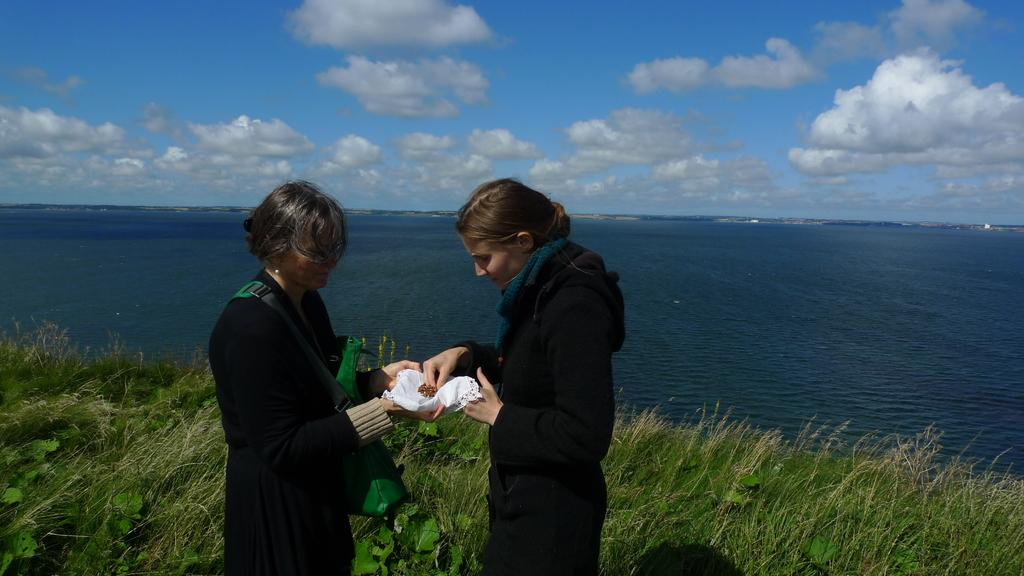How many people are in the image? There are two persons standing in the image. What are the persons holding in the image? The persons are holding an object. What type of natural environment is visible in the image? There is grass, plants, and water visible in the image. What can be seen in the background of the image? The sky is visible in the background of the image. What type of clam is visible on the sofa in the image? There is no clam or sofa present in the image. What is the relation between the two persons in the image? The provided facts do not mention any specific relation between the two persons. 